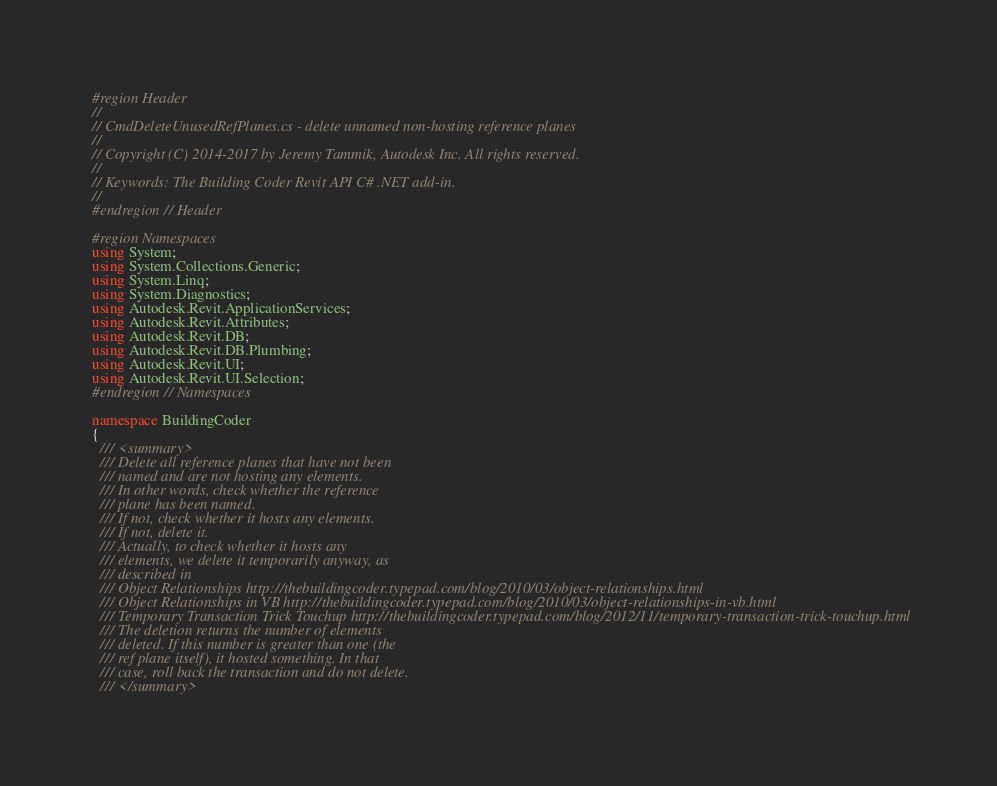<code> <loc_0><loc_0><loc_500><loc_500><_C#_>#region Header
//
// CmdDeleteUnusedRefPlanes.cs - delete unnamed non-hosting reference planes
//
// Copyright (C) 2014-2017 by Jeremy Tammik, Autodesk Inc. All rights reserved.
//
// Keywords: The Building Coder Revit API C# .NET add-in.
//
#endregion // Header

#region Namespaces
using System;
using System.Collections.Generic;
using System.Linq;
using System.Diagnostics;
using Autodesk.Revit.ApplicationServices;
using Autodesk.Revit.Attributes;
using Autodesk.Revit.DB;
using Autodesk.Revit.DB.Plumbing;
using Autodesk.Revit.UI;
using Autodesk.Revit.UI.Selection;
#endregion // Namespaces

namespace BuildingCoder
{
  /// <summary>
  /// Delete all reference planes that have not been 
  /// named and are not hosting any elements.
  /// In other words, check whether the reference 
  /// plane has been named.
  /// If not, check whether it hosts any elements.
  /// If not, delete it.
  /// Actually, to check whether it hosts any 
  /// elements, we delete it temporarily anyway, as
  /// described in
  /// Object Relationships http://thebuildingcoder.typepad.com/blog/2010/03/object-relationships.html
  /// Object Relationships in VB http://thebuildingcoder.typepad.com/blog/2010/03/object-relationships-in-vb.html
  /// Temporary Transaction Trick Touchup http://thebuildingcoder.typepad.com/blog/2012/11/temporary-transaction-trick-touchup.html
  /// The deletion returns the number of elements 
  /// deleted. If this number is greater than one (the 
  /// ref plane itself), it hosted something. In that 
  /// case, roll back the transaction and do not delete.
  /// </summary></code> 